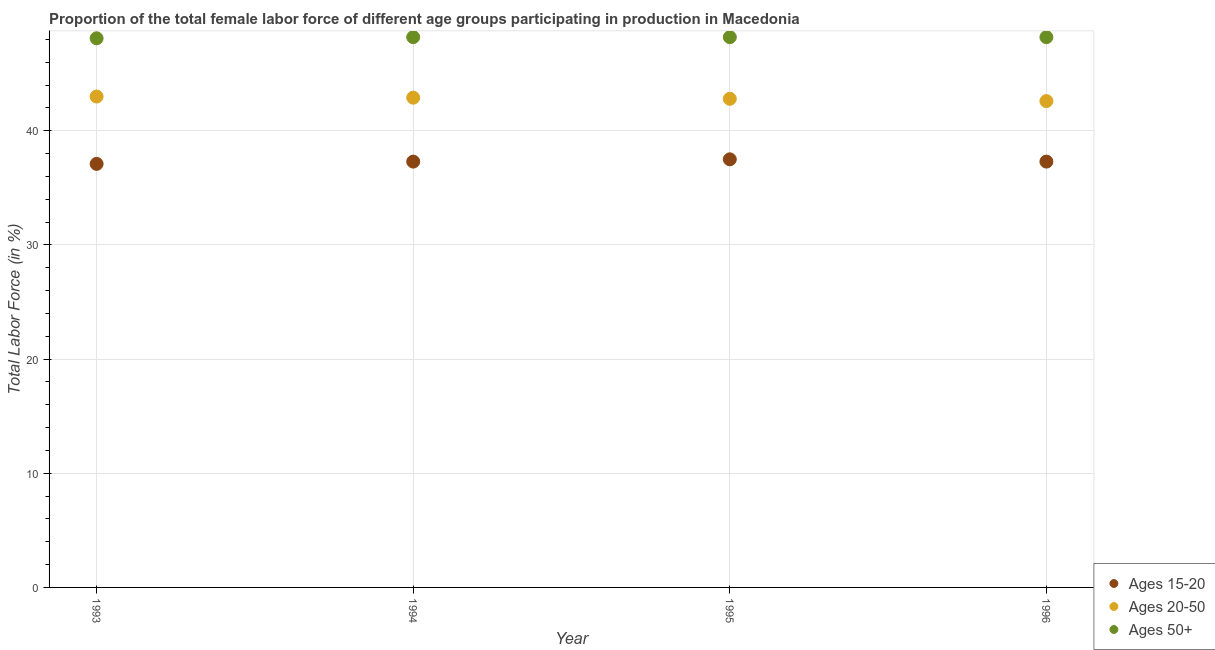How many different coloured dotlines are there?
Offer a terse response. 3. What is the percentage of female labor force within the age group 15-20 in 1996?
Your answer should be very brief. 37.3. Across all years, what is the maximum percentage of female labor force within the age group 15-20?
Provide a short and direct response. 37.5. Across all years, what is the minimum percentage of female labor force within the age group 20-50?
Keep it short and to the point. 42.6. In which year was the percentage of female labor force above age 50 minimum?
Your response must be concise. 1993. What is the total percentage of female labor force within the age group 20-50 in the graph?
Your answer should be very brief. 171.3. What is the difference between the percentage of female labor force within the age group 15-20 in 1993 and that in 1995?
Ensure brevity in your answer.  -0.4. What is the difference between the percentage of female labor force above age 50 in 1993 and the percentage of female labor force within the age group 15-20 in 1996?
Ensure brevity in your answer.  10.8. What is the average percentage of female labor force above age 50 per year?
Your response must be concise. 48.18. In the year 1995, what is the difference between the percentage of female labor force above age 50 and percentage of female labor force within the age group 20-50?
Keep it short and to the point. 5.4. In how many years, is the percentage of female labor force above age 50 greater than 24 %?
Provide a succinct answer. 4. What is the ratio of the percentage of female labor force within the age group 15-20 in 1993 to that in 1996?
Give a very brief answer. 0.99. What is the difference between the highest and the lowest percentage of female labor force above age 50?
Your response must be concise. 0.1. In how many years, is the percentage of female labor force above age 50 greater than the average percentage of female labor force above age 50 taken over all years?
Provide a succinct answer. 3. Does the percentage of female labor force within the age group 20-50 monotonically increase over the years?
Offer a very short reply. No. What is the difference between two consecutive major ticks on the Y-axis?
Your response must be concise. 10. Are the values on the major ticks of Y-axis written in scientific E-notation?
Offer a very short reply. No. Does the graph contain grids?
Provide a succinct answer. Yes. What is the title of the graph?
Provide a succinct answer. Proportion of the total female labor force of different age groups participating in production in Macedonia. Does "Infant(female)" appear as one of the legend labels in the graph?
Offer a very short reply. No. What is the label or title of the X-axis?
Provide a short and direct response. Year. What is the label or title of the Y-axis?
Make the answer very short. Total Labor Force (in %). What is the Total Labor Force (in %) in Ages 15-20 in 1993?
Your response must be concise. 37.1. What is the Total Labor Force (in %) of Ages 20-50 in 1993?
Ensure brevity in your answer.  43. What is the Total Labor Force (in %) of Ages 50+ in 1993?
Keep it short and to the point. 48.1. What is the Total Labor Force (in %) in Ages 15-20 in 1994?
Your response must be concise. 37.3. What is the Total Labor Force (in %) of Ages 20-50 in 1994?
Offer a very short reply. 42.9. What is the Total Labor Force (in %) in Ages 50+ in 1994?
Give a very brief answer. 48.2. What is the Total Labor Force (in %) in Ages 15-20 in 1995?
Provide a short and direct response. 37.5. What is the Total Labor Force (in %) of Ages 20-50 in 1995?
Your answer should be very brief. 42.8. What is the Total Labor Force (in %) of Ages 50+ in 1995?
Offer a terse response. 48.2. What is the Total Labor Force (in %) in Ages 15-20 in 1996?
Your answer should be very brief. 37.3. What is the Total Labor Force (in %) of Ages 20-50 in 1996?
Your answer should be very brief. 42.6. What is the Total Labor Force (in %) in Ages 50+ in 1996?
Keep it short and to the point. 48.2. Across all years, what is the maximum Total Labor Force (in %) of Ages 15-20?
Your answer should be compact. 37.5. Across all years, what is the maximum Total Labor Force (in %) of Ages 20-50?
Give a very brief answer. 43. Across all years, what is the maximum Total Labor Force (in %) in Ages 50+?
Make the answer very short. 48.2. Across all years, what is the minimum Total Labor Force (in %) in Ages 15-20?
Give a very brief answer. 37.1. Across all years, what is the minimum Total Labor Force (in %) in Ages 20-50?
Ensure brevity in your answer.  42.6. Across all years, what is the minimum Total Labor Force (in %) of Ages 50+?
Keep it short and to the point. 48.1. What is the total Total Labor Force (in %) in Ages 15-20 in the graph?
Your response must be concise. 149.2. What is the total Total Labor Force (in %) in Ages 20-50 in the graph?
Provide a succinct answer. 171.3. What is the total Total Labor Force (in %) of Ages 50+ in the graph?
Offer a terse response. 192.7. What is the difference between the Total Labor Force (in %) of Ages 15-20 in 1993 and that in 1995?
Offer a very short reply. -0.4. What is the difference between the Total Labor Force (in %) in Ages 20-50 in 1993 and that in 1995?
Provide a short and direct response. 0.2. What is the difference between the Total Labor Force (in %) in Ages 50+ in 1993 and that in 1995?
Offer a terse response. -0.1. What is the difference between the Total Labor Force (in %) of Ages 15-20 in 1993 and that in 1996?
Make the answer very short. -0.2. What is the difference between the Total Labor Force (in %) of Ages 15-20 in 1994 and that in 1996?
Keep it short and to the point. 0. What is the difference between the Total Labor Force (in %) of Ages 20-50 in 1995 and that in 1996?
Ensure brevity in your answer.  0.2. What is the difference between the Total Labor Force (in %) in Ages 50+ in 1995 and that in 1996?
Your answer should be very brief. 0. What is the difference between the Total Labor Force (in %) of Ages 15-20 in 1993 and the Total Labor Force (in %) of Ages 20-50 in 1994?
Give a very brief answer. -5.8. What is the difference between the Total Labor Force (in %) in Ages 15-20 in 1993 and the Total Labor Force (in %) in Ages 50+ in 1994?
Your answer should be very brief. -11.1. What is the difference between the Total Labor Force (in %) in Ages 20-50 in 1993 and the Total Labor Force (in %) in Ages 50+ in 1994?
Provide a succinct answer. -5.2. What is the difference between the Total Labor Force (in %) in Ages 15-20 in 1993 and the Total Labor Force (in %) in Ages 50+ in 1995?
Offer a terse response. -11.1. What is the difference between the Total Labor Force (in %) in Ages 20-50 in 1993 and the Total Labor Force (in %) in Ages 50+ in 1995?
Keep it short and to the point. -5.2. What is the difference between the Total Labor Force (in %) in Ages 15-20 in 1993 and the Total Labor Force (in %) in Ages 20-50 in 1996?
Provide a short and direct response. -5.5. What is the difference between the Total Labor Force (in %) of Ages 15-20 in 1993 and the Total Labor Force (in %) of Ages 50+ in 1996?
Make the answer very short. -11.1. What is the difference between the Total Labor Force (in %) in Ages 20-50 in 1993 and the Total Labor Force (in %) in Ages 50+ in 1996?
Provide a short and direct response. -5.2. What is the difference between the Total Labor Force (in %) of Ages 15-20 in 1994 and the Total Labor Force (in %) of Ages 20-50 in 1996?
Keep it short and to the point. -5.3. What is the difference between the Total Labor Force (in %) of Ages 20-50 in 1994 and the Total Labor Force (in %) of Ages 50+ in 1996?
Keep it short and to the point. -5.3. What is the difference between the Total Labor Force (in %) in Ages 15-20 in 1995 and the Total Labor Force (in %) in Ages 20-50 in 1996?
Offer a terse response. -5.1. What is the average Total Labor Force (in %) of Ages 15-20 per year?
Provide a short and direct response. 37.3. What is the average Total Labor Force (in %) in Ages 20-50 per year?
Your answer should be very brief. 42.83. What is the average Total Labor Force (in %) of Ages 50+ per year?
Make the answer very short. 48.17. In the year 1993, what is the difference between the Total Labor Force (in %) in Ages 20-50 and Total Labor Force (in %) in Ages 50+?
Offer a very short reply. -5.1. In the year 1994, what is the difference between the Total Labor Force (in %) in Ages 15-20 and Total Labor Force (in %) in Ages 20-50?
Ensure brevity in your answer.  -5.6. In the year 1994, what is the difference between the Total Labor Force (in %) in Ages 15-20 and Total Labor Force (in %) in Ages 50+?
Your answer should be compact. -10.9. In the year 1994, what is the difference between the Total Labor Force (in %) in Ages 20-50 and Total Labor Force (in %) in Ages 50+?
Keep it short and to the point. -5.3. In the year 1995, what is the difference between the Total Labor Force (in %) of Ages 15-20 and Total Labor Force (in %) of Ages 50+?
Offer a very short reply. -10.7. In the year 1995, what is the difference between the Total Labor Force (in %) in Ages 20-50 and Total Labor Force (in %) in Ages 50+?
Provide a short and direct response. -5.4. In the year 1996, what is the difference between the Total Labor Force (in %) in Ages 15-20 and Total Labor Force (in %) in Ages 20-50?
Your answer should be very brief. -5.3. In the year 1996, what is the difference between the Total Labor Force (in %) in Ages 15-20 and Total Labor Force (in %) in Ages 50+?
Your response must be concise. -10.9. What is the ratio of the Total Labor Force (in %) of Ages 15-20 in 1993 to that in 1994?
Keep it short and to the point. 0.99. What is the ratio of the Total Labor Force (in %) in Ages 20-50 in 1993 to that in 1994?
Your answer should be very brief. 1. What is the ratio of the Total Labor Force (in %) of Ages 50+ in 1993 to that in 1994?
Your answer should be compact. 1. What is the ratio of the Total Labor Force (in %) in Ages 15-20 in 1993 to that in 1995?
Make the answer very short. 0.99. What is the ratio of the Total Labor Force (in %) in Ages 50+ in 1993 to that in 1995?
Offer a terse response. 1. What is the ratio of the Total Labor Force (in %) of Ages 20-50 in 1993 to that in 1996?
Your response must be concise. 1.01. What is the ratio of the Total Labor Force (in %) of Ages 50+ in 1993 to that in 1996?
Your answer should be compact. 1. What is the ratio of the Total Labor Force (in %) in Ages 50+ in 1994 to that in 1995?
Offer a very short reply. 1. What is the ratio of the Total Labor Force (in %) of Ages 20-50 in 1994 to that in 1996?
Offer a very short reply. 1.01. What is the ratio of the Total Labor Force (in %) of Ages 15-20 in 1995 to that in 1996?
Ensure brevity in your answer.  1.01. What is the ratio of the Total Labor Force (in %) of Ages 20-50 in 1995 to that in 1996?
Provide a short and direct response. 1. What is the difference between the highest and the second highest Total Labor Force (in %) of Ages 15-20?
Offer a terse response. 0.2. What is the difference between the highest and the second highest Total Labor Force (in %) in Ages 50+?
Keep it short and to the point. 0. What is the difference between the highest and the lowest Total Labor Force (in %) of Ages 15-20?
Your answer should be very brief. 0.4. 